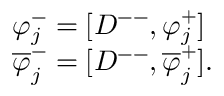<formula> <loc_0><loc_0><loc_500><loc_500>\begin{array} { l c r } { { \varphi _ { j } ^ { - } = [ D ^ { - - } , \varphi _ { j } ^ { + } ] } } \\ { { \overline { \varphi } _ { j } ^ { - } = [ D ^ { - - } , \overline { \varphi } _ { j } ^ { + } ] . } } \end{array}</formula> 